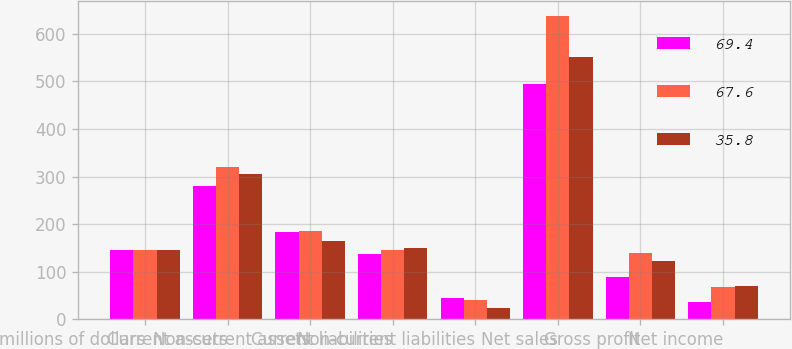<chart> <loc_0><loc_0><loc_500><loc_500><stacked_bar_chart><ecel><fcel>millions of dollars<fcel>Current assets<fcel>Non-current assets<fcel>Current liabilities<fcel>Non-current liabilities<fcel>Net sales<fcel>Gross profit<fcel>Net income<nl><fcel>69.4<fcel>146.3<fcel>279.1<fcel>182.6<fcel>137.9<fcel>45<fcel>494.5<fcel>89.2<fcel>35.8<nl><fcel>67.6<fcel>146.3<fcel>319.1<fcel>185.7<fcel>146.3<fcel>40.5<fcel>637.9<fcel>140<fcel>67.6<nl><fcel>35.8<fcel>146.3<fcel>304.6<fcel>164.3<fcel>148.8<fcel>22.9<fcel>552.1<fcel>122.7<fcel>69.4<nl></chart> 